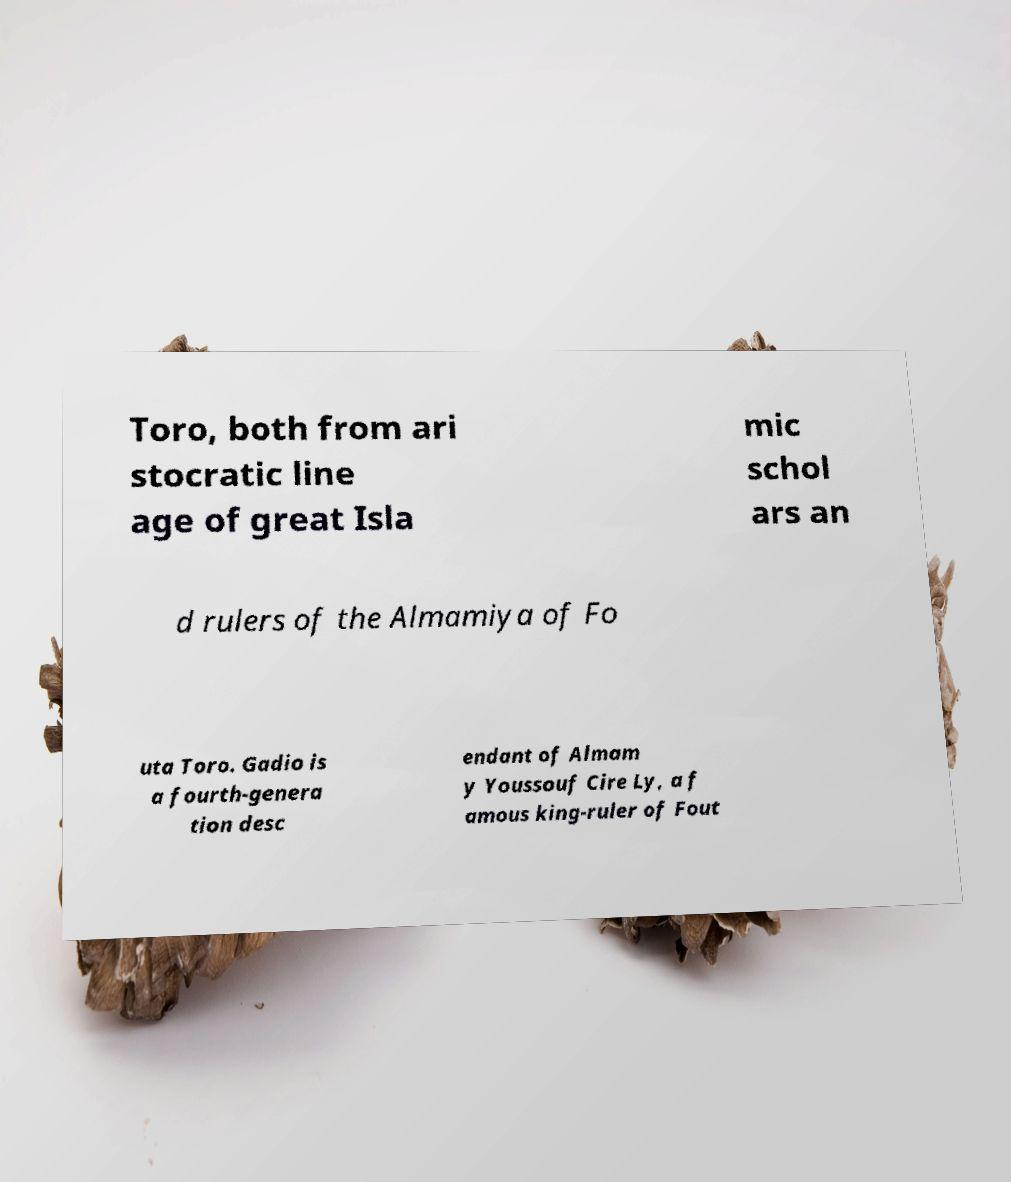Could you extract and type out the text from this image? Toro, both from ari stocratic line age of great Isla mic schol ars an d rulers of the Almamiya of Fo uta Toro. Gadio is a fourth-genera tion desc endant of Almam y Youssouf Cire Ly, a f amous king-ruler of Fout 